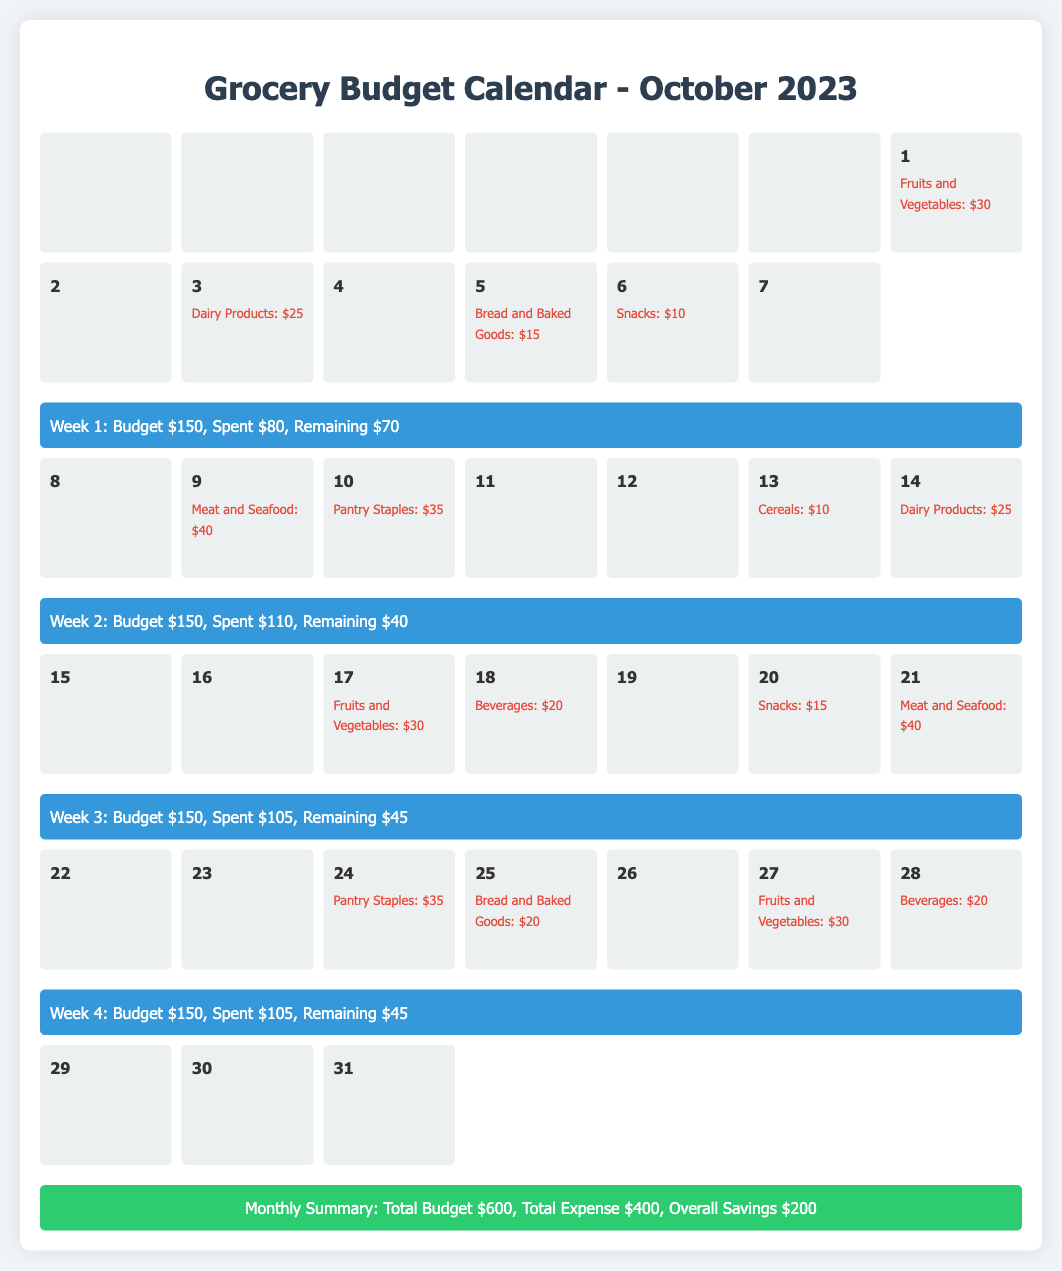What is the budget for Week 1? The budget for Week 1 is specified in the week summary section for that week.
Answer: $150 What is the total expense for October 2023? The total expense is found in the monthly summary section of the document.
Answer: $400 How much was spent on Dairy Products in Week 2? The expense for Dairy Products for that week can be found in the daily entries.
Answer: $25 What is the remaining budget at the end of Week 3? The remaining budget is indicated in the week summary for Week 3.
Answer: $45 What was the expense for Fruits and Vegetables on October 1st? The specific expense can be retrieved from the day entry for October 1st.
Answer: $30 What is the total budget for the month? The total budget is outlined in the monthly summary section of the document.
Answer: $600 How many expenses are listed for Week 4? The number of expenses can be counted from the daily entries for that week.
Answer: 4 What types of groceries were purchased on October 10th? The type of groceries can be retrieved from the expense entry for that day.
Answer: Pantry Staples What is the overall savings for October 2023? The overall savings is mentioned in the monthly summary section of the document.
Answer: $200 